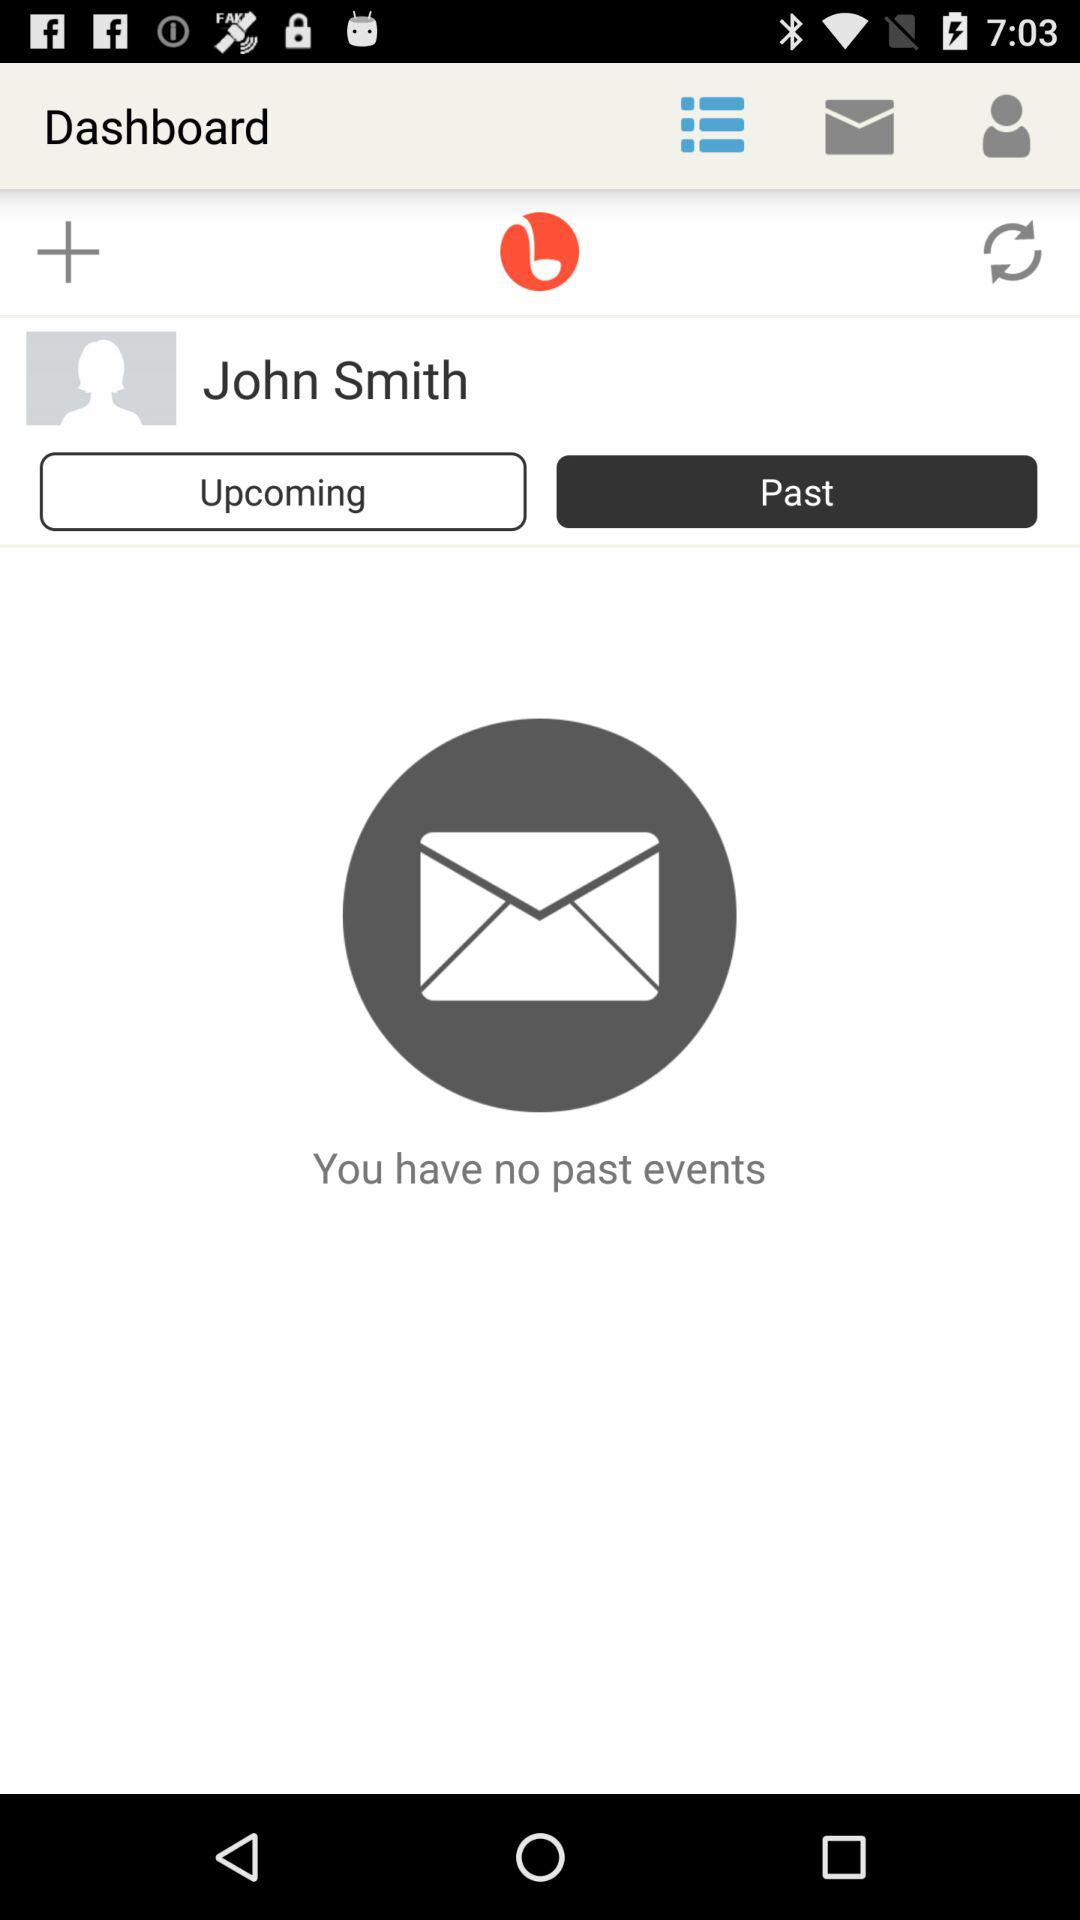How many events are there in total?
Answer the question using a single word or phrase. 0 